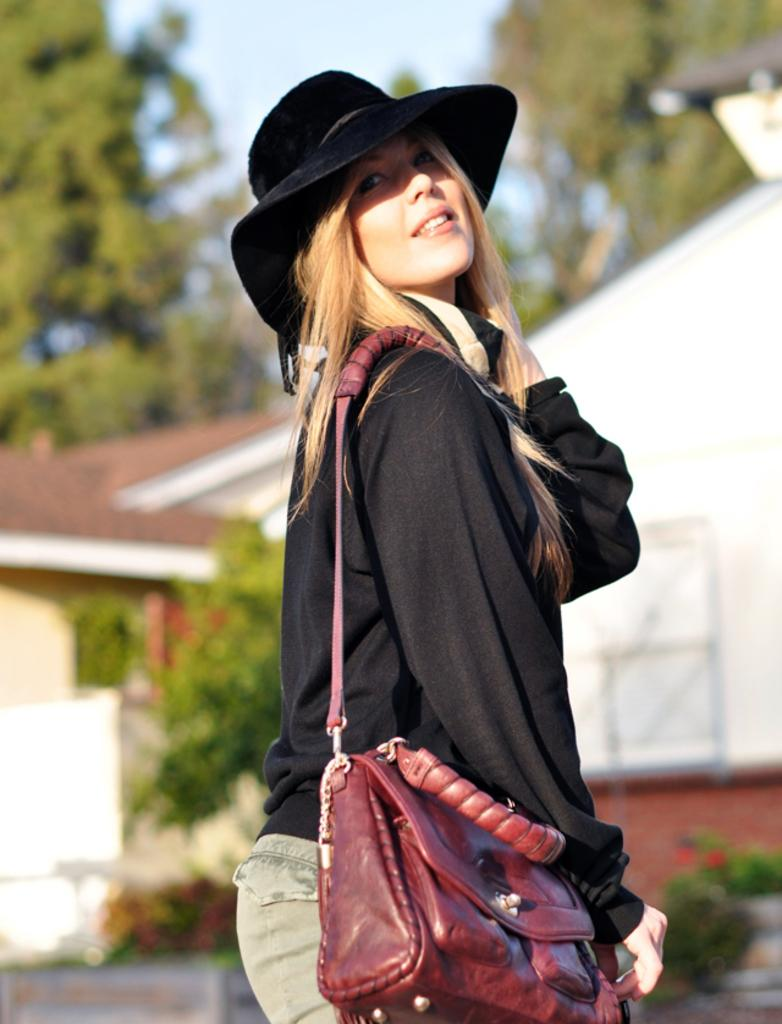Who is the main subject in the image? There is a woman in the center of the image. What is the woman doing in the image? The woman is standing. What is the woman holding in the image? The woman is holding a handbag. What is the woman wearing on her head in the image? The woman is wearing a hat. What can be seen in the background of the image? There is a tree, the sky, a house, and a wall visible in the background of the image. Can you tell me how many ducks are swimming in the stream in the image? There is no stream or duck present in the image. What type of health advice can be seen on the wall in the image? There is no health advice visible on the wall in the image. 